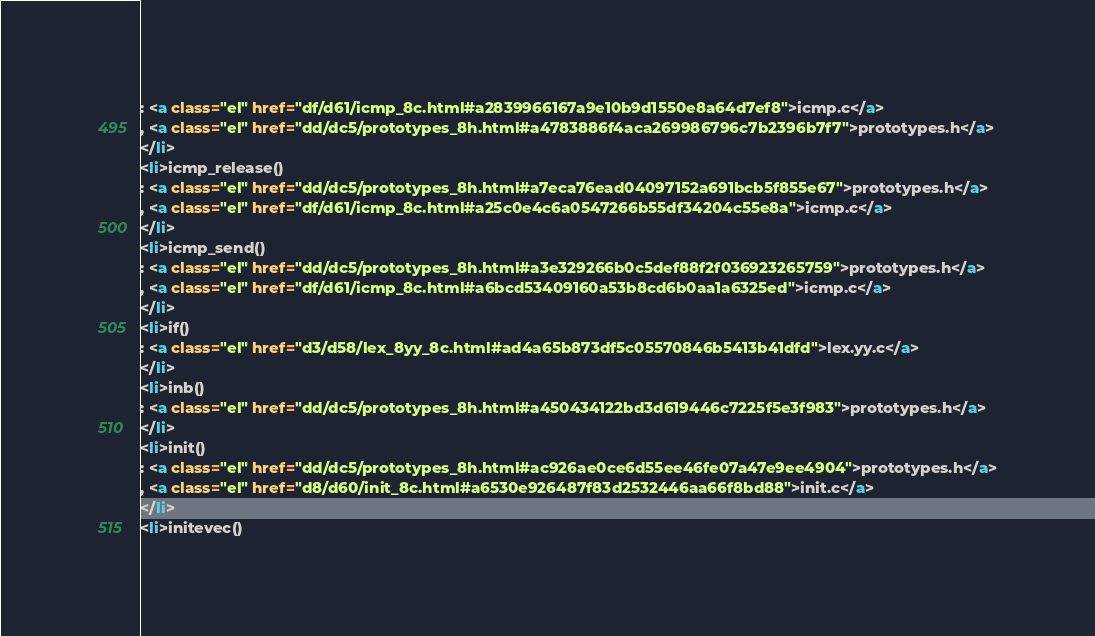Convert code to text. <code><loc_0><loc_0><loc_500><loc_500><_HTML_>: <a class="el" href="df/d61/icmp_8c.html#a2839966167a9e10b9d1550e8a64d7ef8">icmp.c</a>
, <a class="el" href="dd/dc5/prototypes_8h.html#a4783886f4aca269986796c7b2396b7f7">prototypes.h</a>
</li>
<li>icmp_release()
: <a class="el" href="dd/dc5/prototypes_8h.html#a7eca76ead04097152a691bcb5f855e67">prototypes.h</a>
, <a class="el" href="df/d61/icmp_8c.html#a25c0e4c6a0547266b55df34204c55e8a">icmp.c</a>
</li>
<li>icmp_send()
: <a class="el" href="dd/dc5/prototypes_8h.html#a3e329266b0c5def88f2f036923265759">prototypes.h</a>
, <a class="el" href="df/d61/icmp_8c.html#a6bcd53409160a53b8cd6b0aa1a6325ed">icmp.c</a>
</li>
<li>if()
: <a class="el" href="d3/d58/lex_8yy_8c.html#ad4a65b873df5c05570846b5413b41dfd">lex.yy.c</a>
</li>
<li>inb()
: <a class="el" href="dd/dc5/prototypes_8h.html#a450434122bd3d619446c7225f5e3f983">prototypes.h</a>
</li>
<li>init()
: <a class="el" href="dd/dc5/prototypes_8h.html#ac926ae0ce6d55ee46fe07a47e9ee4904">prototypes.h</a>
, <a class="el" href="d8/d60/init_8c.html#a6530e926487f83d2532446aa66f8bd88">init.c</a>
</li>
<li>initevec()</code> 